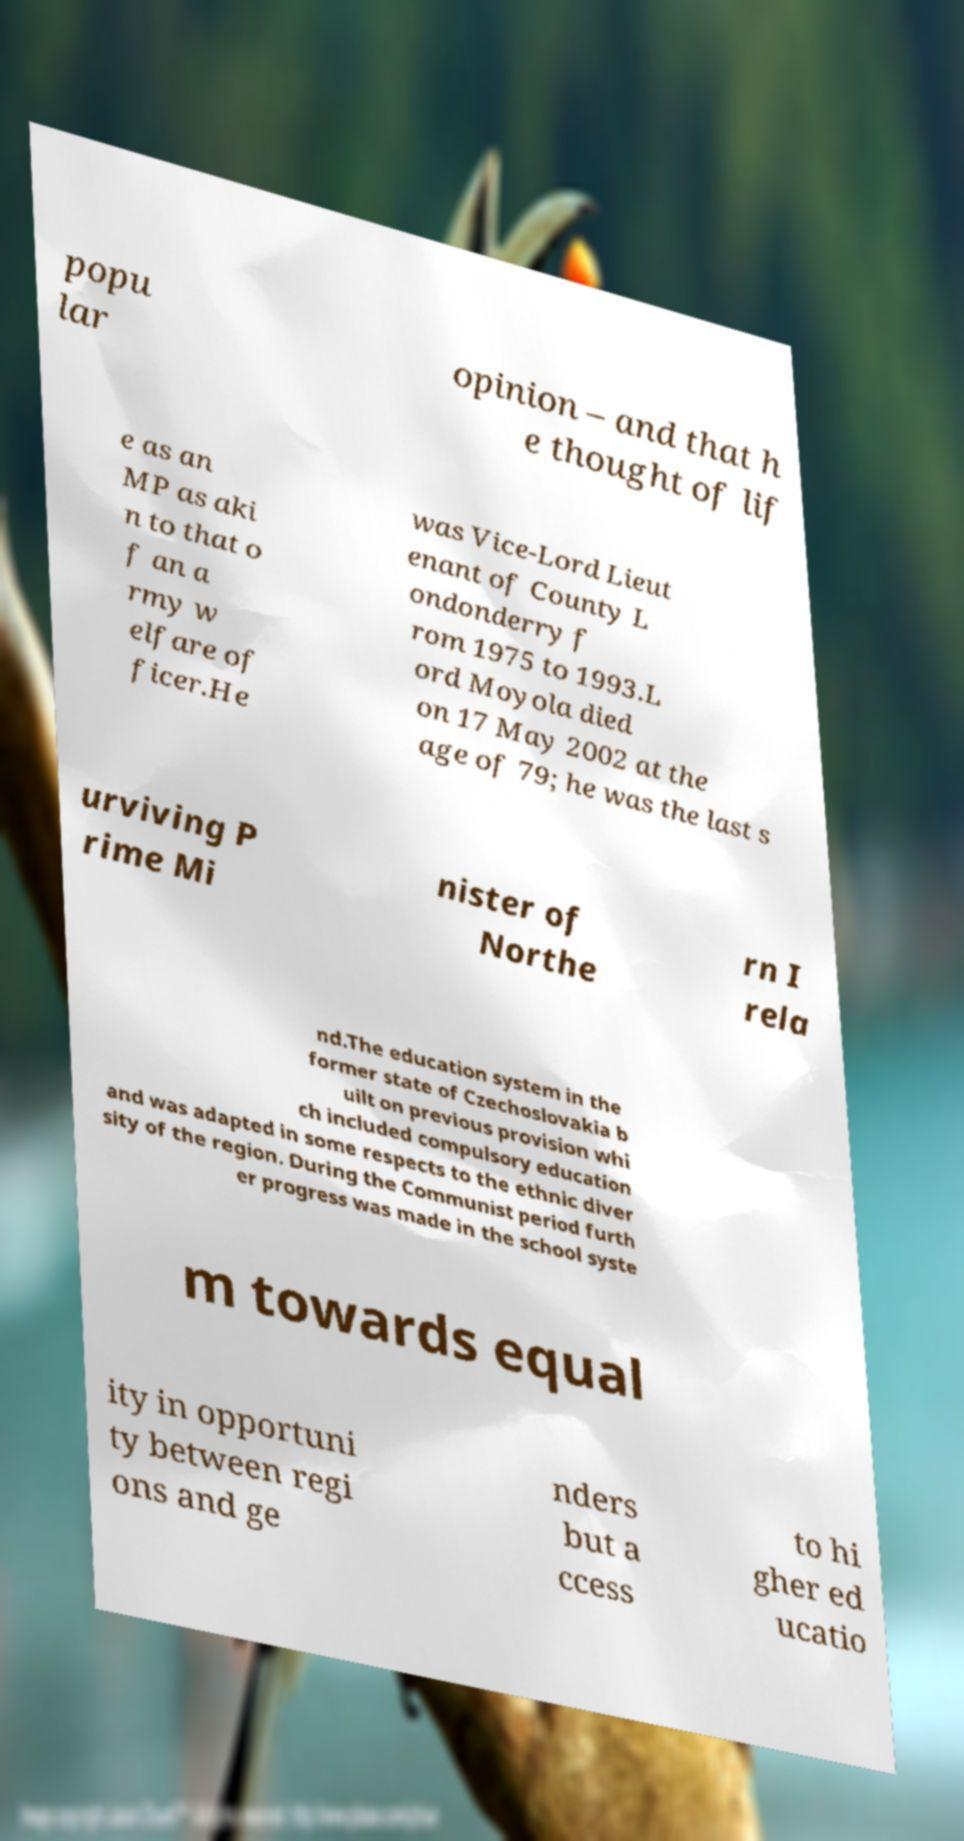There's text embedded in this image that I need extracted. Can you transcribe it verbatim? popu lar opinion – and that h e thought of lif e as an MP as aki n to that o f an a rmy w elfare of ficer.He was Vice-Lord Lieut enant of County L ondonderry f rom 1975 to 1993.L ord Moyola died on 17 May 2002 at the age of 79; he was the last s urviving P rime Mi nister of Northe rn I rela nd.The education system in the former state of Czechoslovakia b uilt on previous provision whi ch included compulsory education and was adapted in some respects to the ethnic diver sity of the region. During the Communist period furth er progress was made in the school syste m towards equal ity in opportuni ty between regi ons and ge nders but a ccess to hi gher ed ucatio 